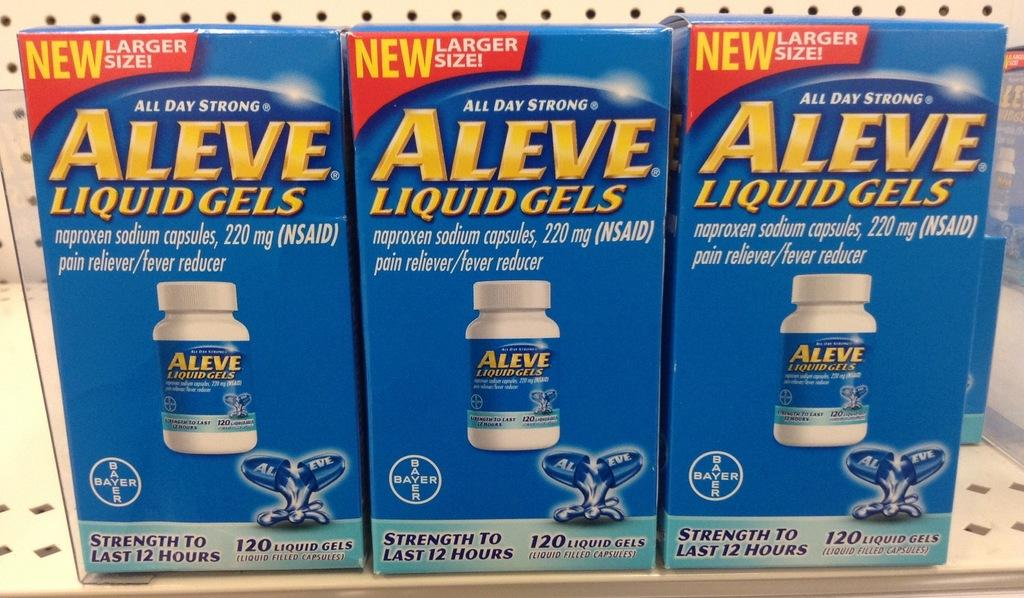Provide a one-sentence caption for the provided image. Three blue and yellow boxes of Aleve Liquid Gels. 